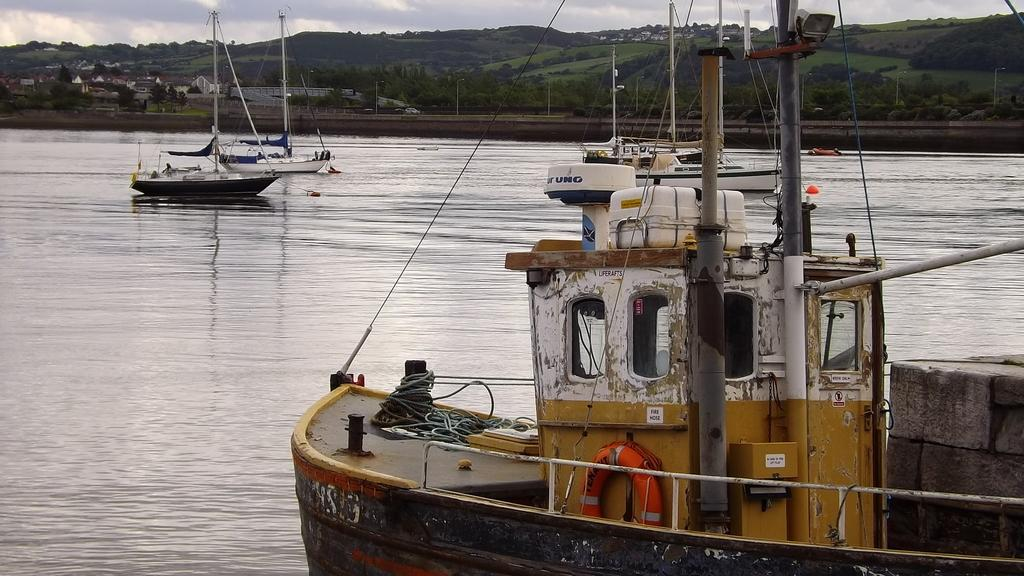What is in the water in the image? There are boats in the water in the image. What is located behind the boats? There is a road behind the boats. What can be seen on the road? There is a lamp post on the road. What type of natural elements are visible in the image? There are trees and mountains visible in the image. What type of structures are present in the image? There are houses in the image. What type of flowers can be seen growing near the houses in the image? There are no flowers visible in the image; only trees, mountains, houses, boats, a road, and a lamp post are present. 